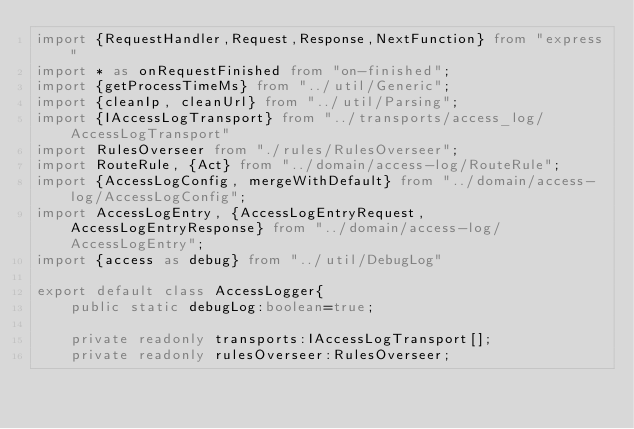<code> <loc_0><loc_0><loc_500><loc_500><_TypeScript_>import {RequestHandler,Request,Response,NextFunction} from "express"
import * as onRequestFinished from "on-finished";
import {getProcessTimeMs} from "../util/Generic";
import {cleanIp, cleanUrl} from "../util/Parsing";
import {IAccessLogTransport} from "../transports/access_log/AccessLogTransport"
import RulesOverseer from "./rules/RulesOverseer";
import RouteRule, {Act} from "../domain/access-log/RouteRule";
import {AccessLogConfig, mergeWithDefault} from "../domain/access-log/AccessLogConfig";
import AccessLogEntry, {AccessLogEntryRequest, AccessLogEntryResponse} from "../domain/access-log/AccessLogEntry";
import {access as debug} from "../util/DebugLog"

export default class AccessLogger{
	public static debugLog:boolean=true;

	private readonly transports:IAccessLogTransport[];
	private readonly rulesOverseer:RulesOverseer;</code> 